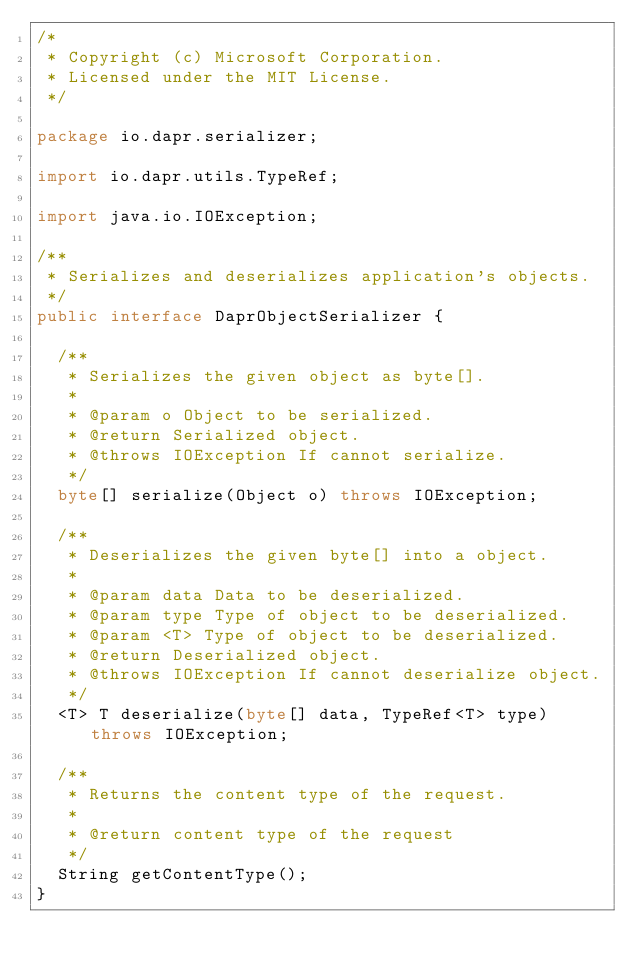Convert code to text. <code><loc_0><loc_0><loc_500><loc_500><_Java_>/*
 * Copyright (c) Microsoft Corporation.
 * Licensed under the MIT License.
 */

package io.dapr.serializer;

import io.dapr.utils.TypeRef;

import java.io.IOException;

/**
 * Serializes and deserializes application's objects.
 */
public interface DaprObjectSerializer {

  /**
   * Serializes the given object as byte[].
   *
   * @param o Object to be serialized.
   * @return Serialized object.
   * @throws IOException If cannot serialize.
   */
  byte[] serialize(Object o) throws IOException;

  /**
   * Deserializes the given byte[] into a object.
   *
   * @param data Data to be deserialized.
   * @param type Type of object to be deserialized.
   * @param <T> Type of object to be deserialized.
   * @return Deserialized object.
   * @throws IOException If cannot deserialize object.
   */
  <T> T deserialize(byte[] data, TypeRef<T> type) throws IOException;

  /**
   * Returns the content type of the request.
   * 
   * @return content type of the request
   */
  String getContentType();
}
</code> 